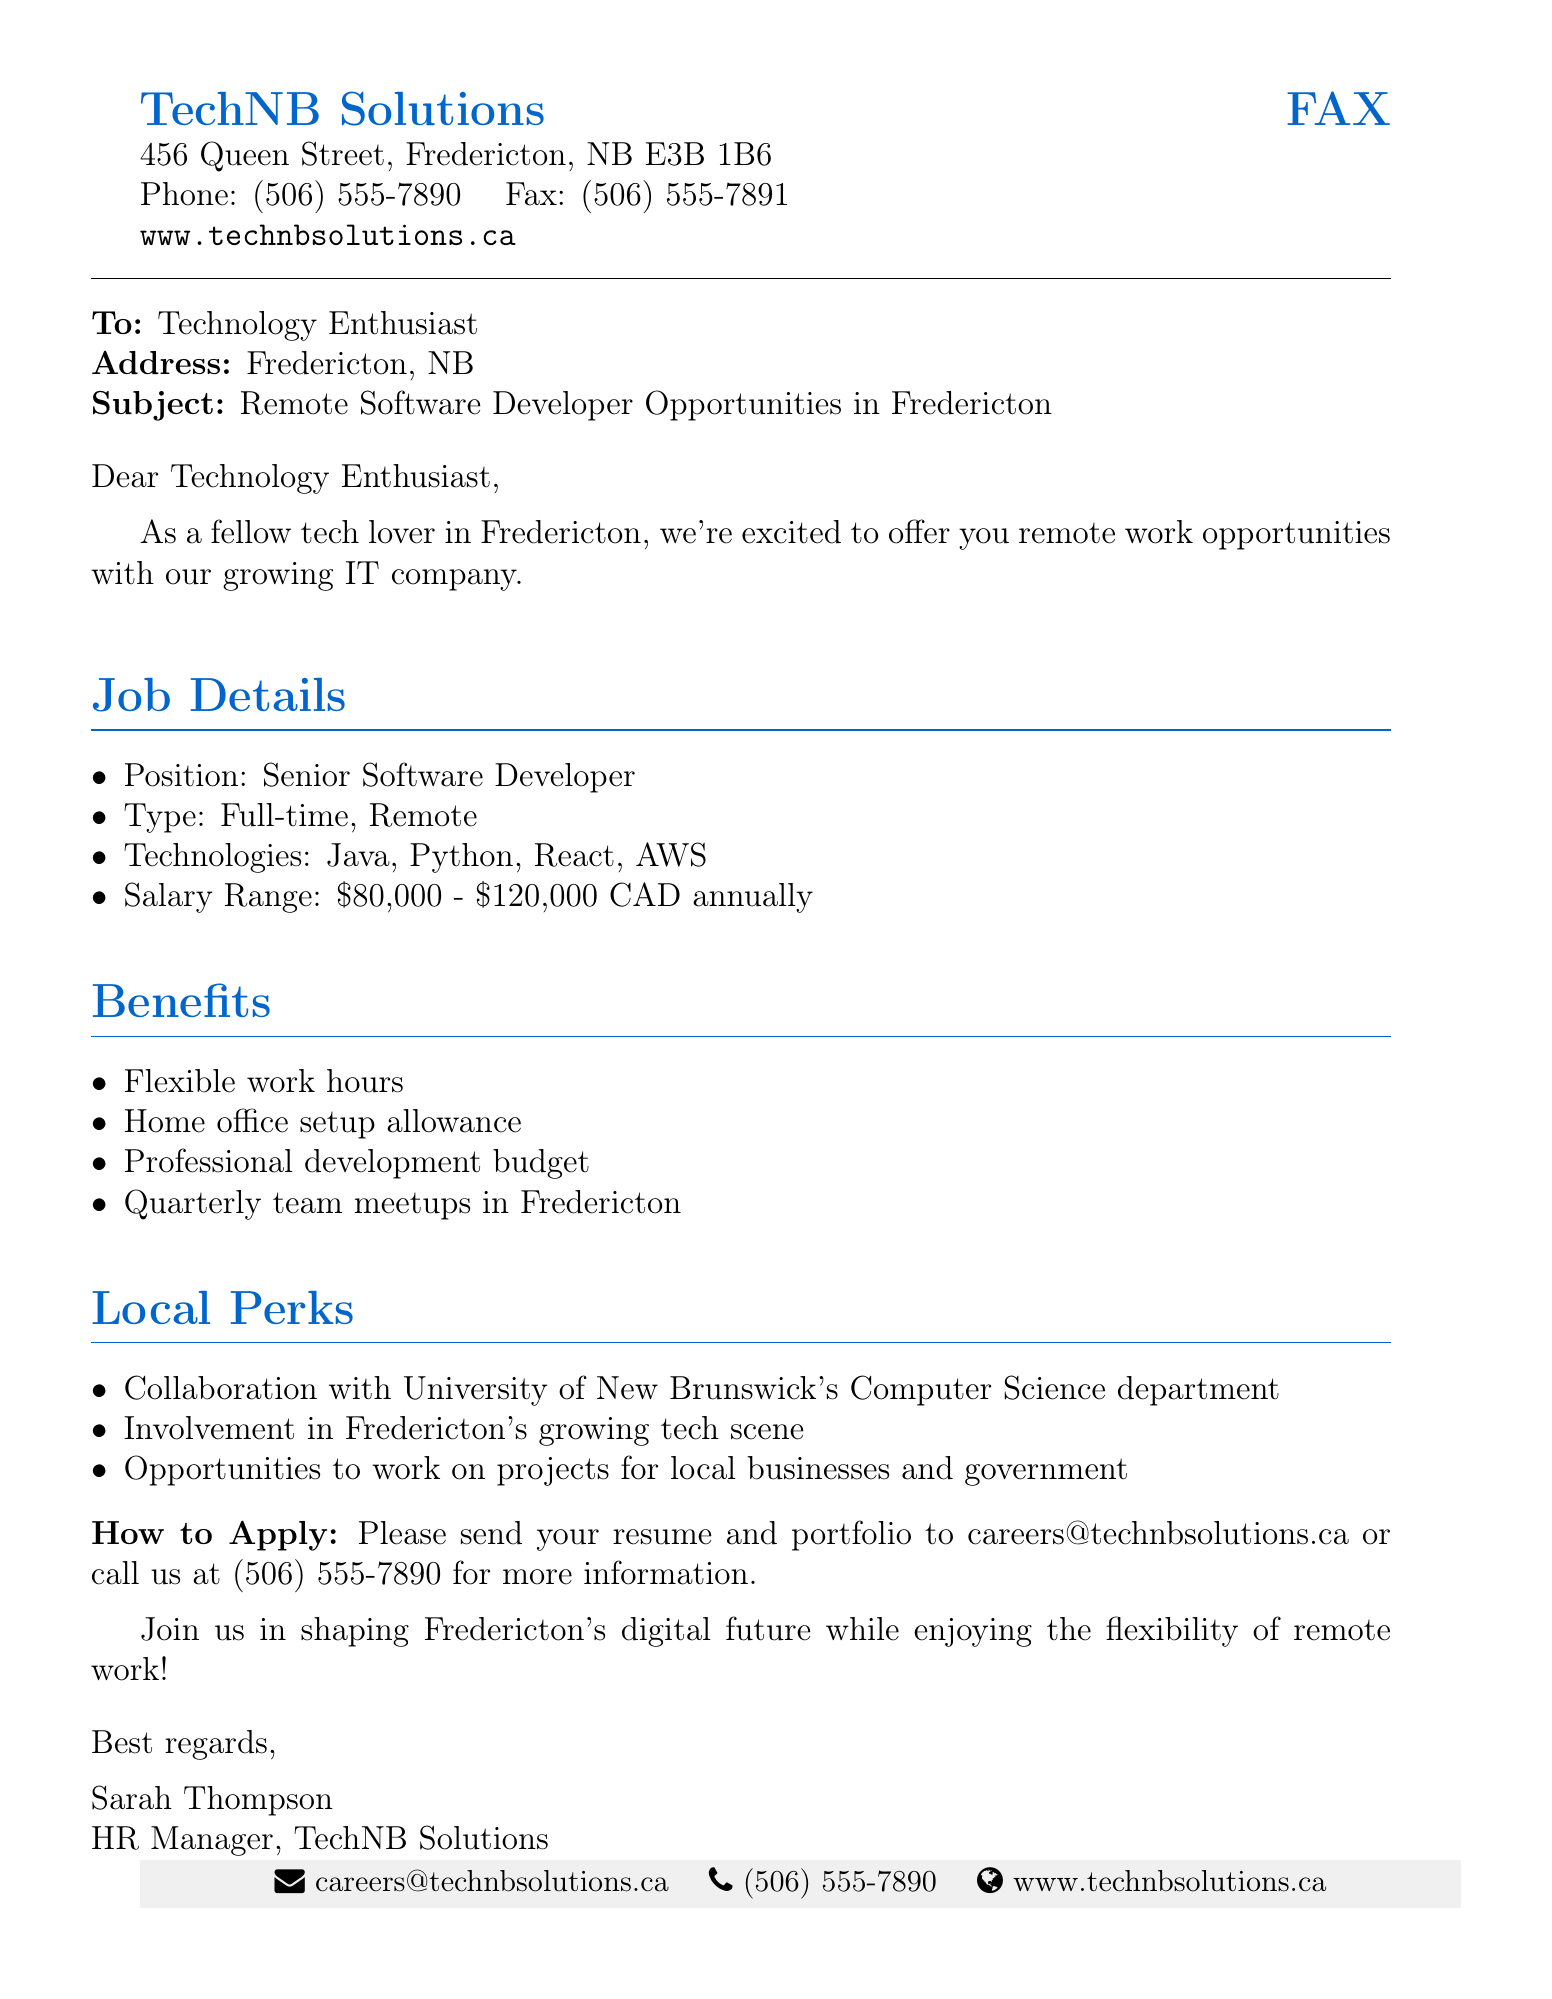What is the position offered? The position offered is stated explicitly in the job details section as "Senior Software Developer."
Answer: Senior Software Developer What is the salary range for the position? The salary range is mentioned in the document, specifically listed as "$80,000 - $120,000 CAD annually."
Answer: $80,000 - $120,000 CAD annually What technologies are required for the job? The document lists the required technologies in the job details section, which are "Java, Python, React, AWS."
Answer: Java, Python, React, AWS What is one of the benefits provided? The benefits provided include a "Home office setup allowance," which is specifically mentioned in the benefits section.
Answer: Home office setup allowance How can applicants apply? The document gives clear instructions on how to apply by stating to send a resume and portfolio to the specified email or call the provided phone number.
Answer: careers@technbsolutions.ca What type of work arrangement is offered? The work arrangement is explicitly described in the document as "Full-time, Remote."
Answer: Full-time, Remote What is one local perk mentioned? One of the local perks included in the document is "Collaboration with University of New Brunswick's Computer Science department."
Answer: Collaboration with University of New Brunswick's Computer Science department Who is the contact person for inquiries? The document identifies "Sarah Thompson" as the HR Manager and the contact person for inquiries.
Answer: Sarah Thompson 